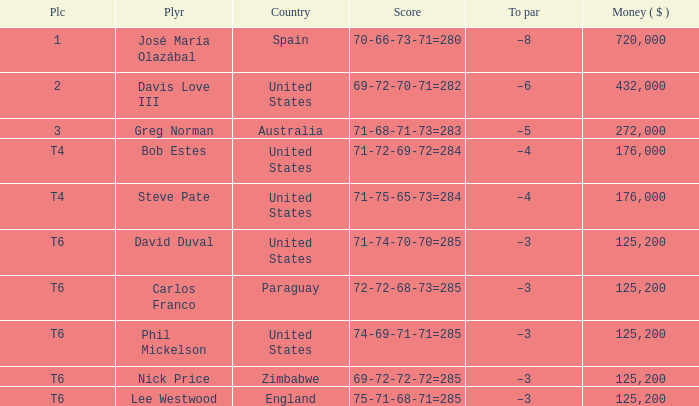Which Score has a Place of t6, and a Country of paraguay? 72-72-68-73=285. 